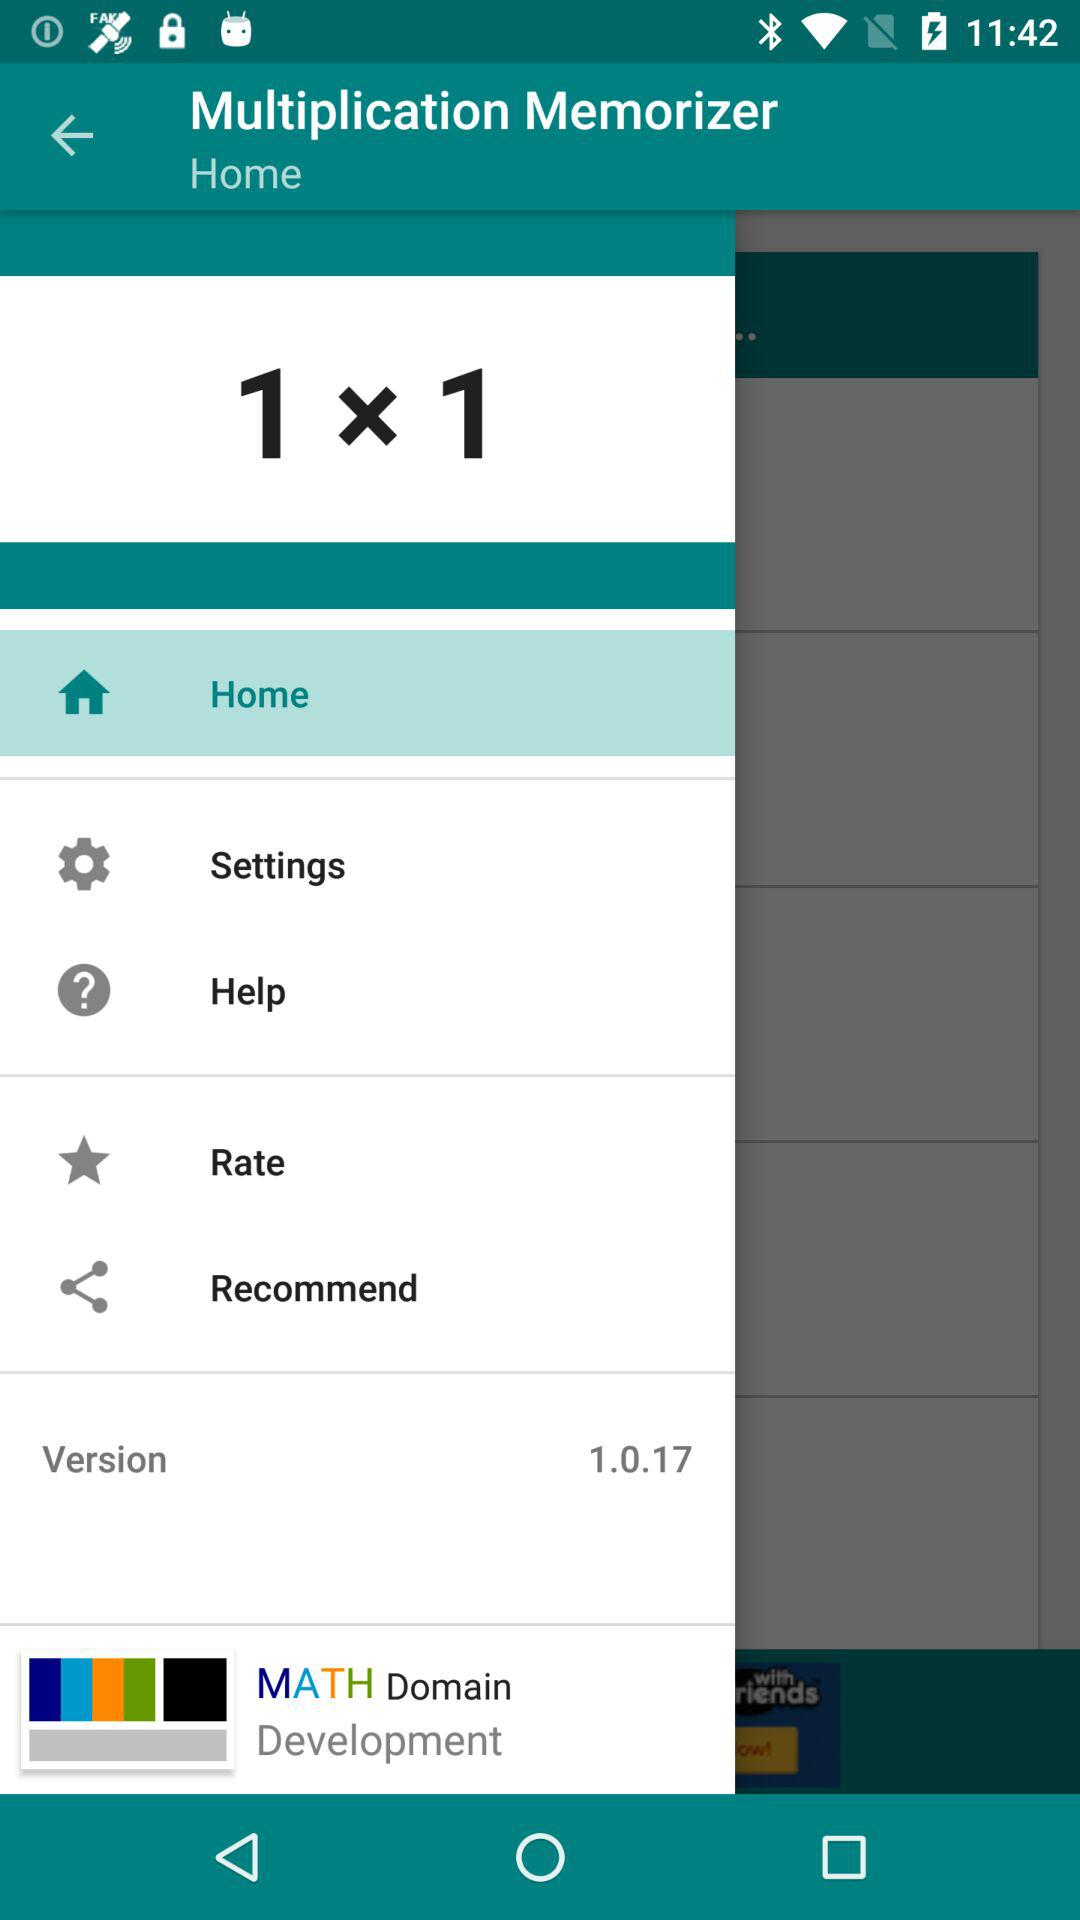Which item is selected? The selected item is "Home". 